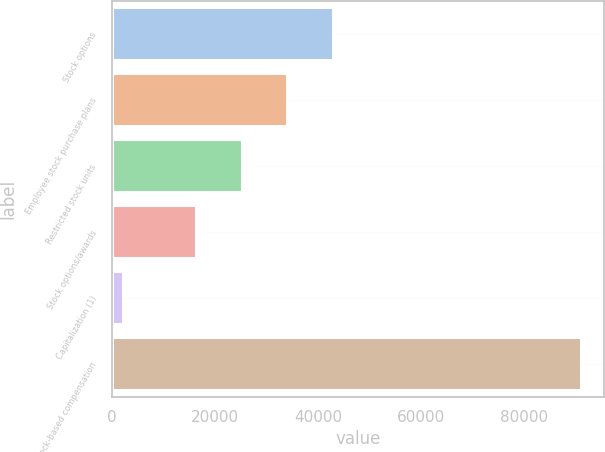<chart> <loc_0><loc_0><loc_500><loc_500><bar_chart><fcel>Stock options<fcel>Employee stock purchase plans<fcel>Restricted stock units<fcel>Stock options/awards<fcel>Capitalization (1)<fcel>Total stock-based compensation<nl><fcel>42923.8<fcel>34044.2<fcel>25164.6<fcel>16285<fcel>2118<fcel>90914<nl></chart> 